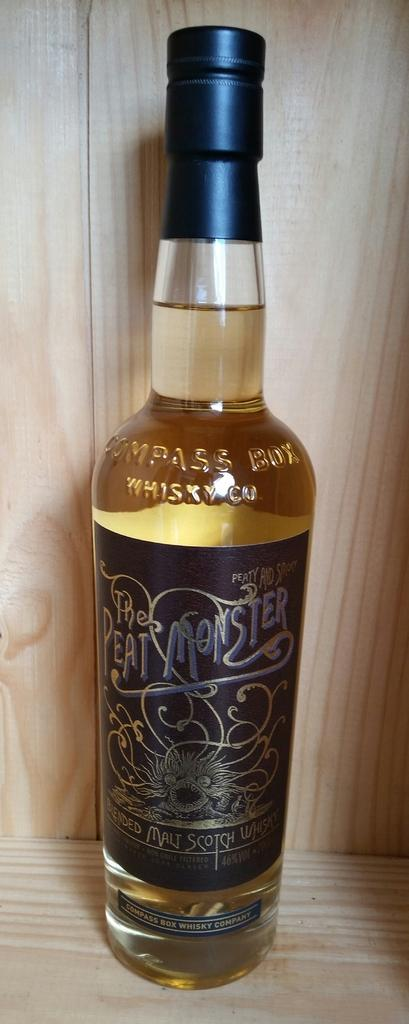<image>
Provide a brief description of the given image. a tall wine bottle that says 'the peat monster' on it 